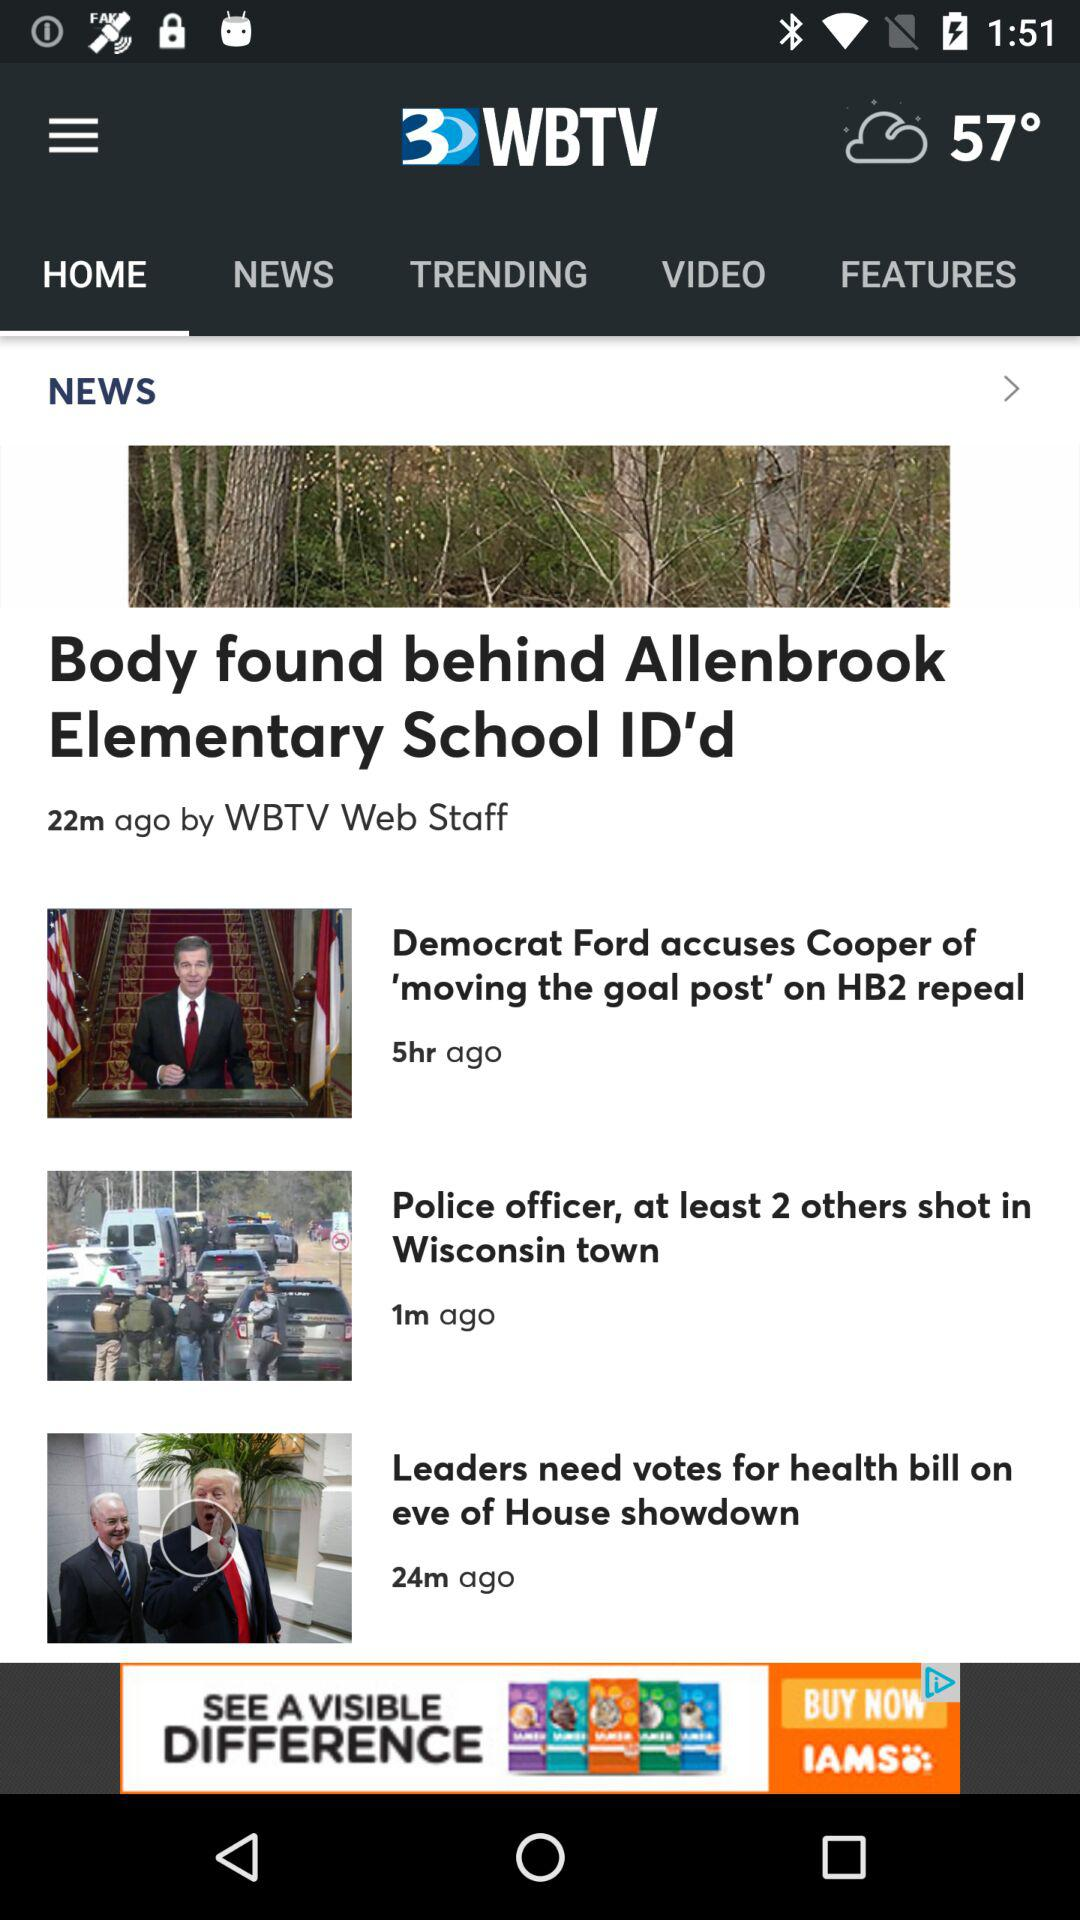What is the name of the application? The name of the application is "3 WBTV". 